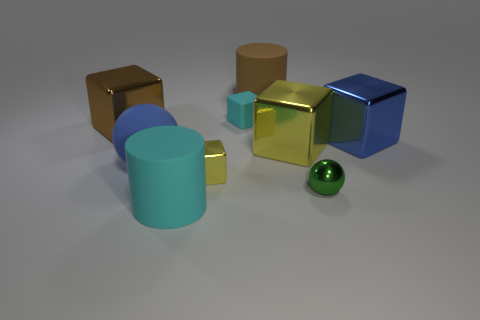Subtract 2 blocks. How many blocks are left? 3 Subtract all cyan blocks. How many blocks are left? 4 Subtract all rubber cubes. How many cubes are left? 4 Subtract all green blocks. Subtract all green cylinders. How many blocks are left? 5 Add 1 blue shiny things. How many objects exist? 10 Subtract all cubes. How many objects are left? 4 Add 8 large cyan metallic objects. How many large cyan metallic objects exist? 8 Subtract 1 cyan cubes. How many objects are left? 8 Subtract all green things. Subtract all cyan rubber things. How many objects are left? 6 Add 9 green metal spheres. How many green metal spheres are left? 10 